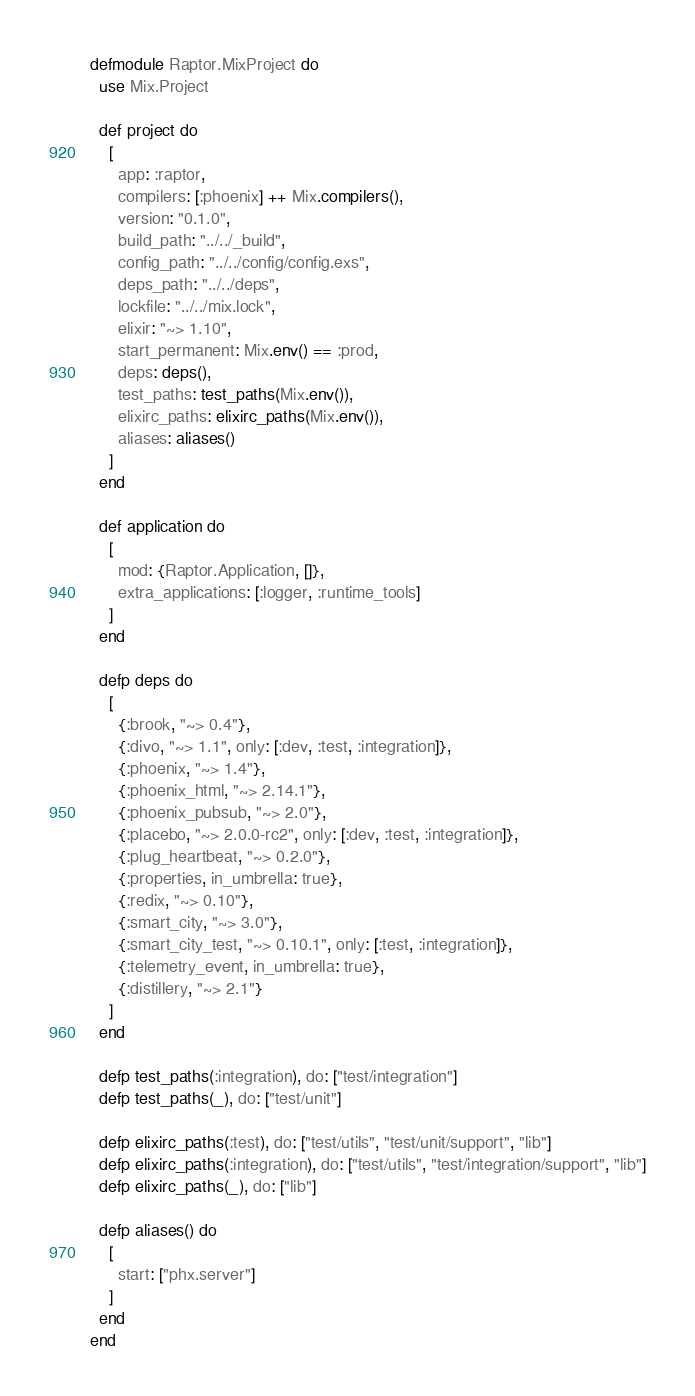Convert code to text. <code><loc_0><loc_0><loc_500><loc_500><_Elixir_>defmodule Raptor.MixProject do
  use Mix.Project

  def project do
    [
      app: :raptor,
      compilers: [:phoenix] ++ Mix.compilers(),
      version: "0.1.0",
      build_path: "../../_build",
      config_path: "../../config/config.exs",
      deps_path: "../../deps",
      lockfile: "../../mix.lock",
      elixir: "~> 1.10",
      start_permanent: Mix.env() == :prod,
      deps: deps(),
      test_paths: test_paths(Mix.env()),
      elixirc_paths: elixirc_paths(Mix.env()),
      aliases: aliases()
    ]
  end

  def application do
    [
      mod: {Raptor.Application, []},
      extra_applications: [:logger, :runtime_tools]
    ]
  end

  defp deps do
    [
      {:brook, "~> 0.4"},
      {:divo, "~> 1.1", only: [:dev, :test, :integration]},
      {:phoenix, "~> 1.4"},
      {:phoenix_html, "~> 2.14.1"},
      {:phoenix_pubsub, "~> 2.0"},
      {:placebo, "~> 2.0.0-rc2", only: [:dev, :test, :integration]},
      {:plug_heartbeat, "~> 0.2.0"},
      {:properties, in_umbrella: true},
      {:redix, "~> 0.10"},
      {:smart_city, "~> 3.0"},
      {:smart_city_test, "~> 0.10.1", only: [:test, :integration]},
      {:telemetry_event, in_umbrella: true},
      {:distillery, "~> 2.1"}
    ]
  end

  defp test_paths(:integration), do: ["test/integration"]
  defp test_paths(_), do: ["test/unit"]

  defp elixirc_paths(:test), do: ["test/utils", "test/unit/support", "lib"]
  defp elixirc_paths(:integration), do: ["test/utils", "test/integration/support", "lib"]
  defp elixirc_paths(_), do: ["lib"]

  defp aliases() do
    [
      start: ["phx.server"]
    ]
  end
end
</code> 